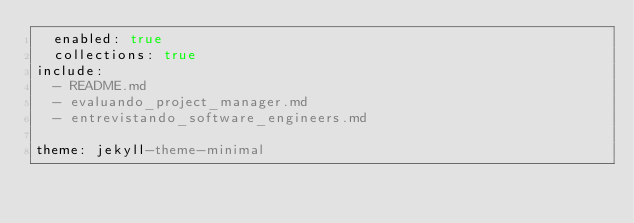Convert code to text. <code><loc_0><loc_0><loc_500><loc_500><_YAML_>  enabled: true
  collections: true
include:
  - README.md
  - evaluando_project_manager.md
  - entrevistando_software_engineers.md

theme: jekyll-theme-minimal 
</code> 